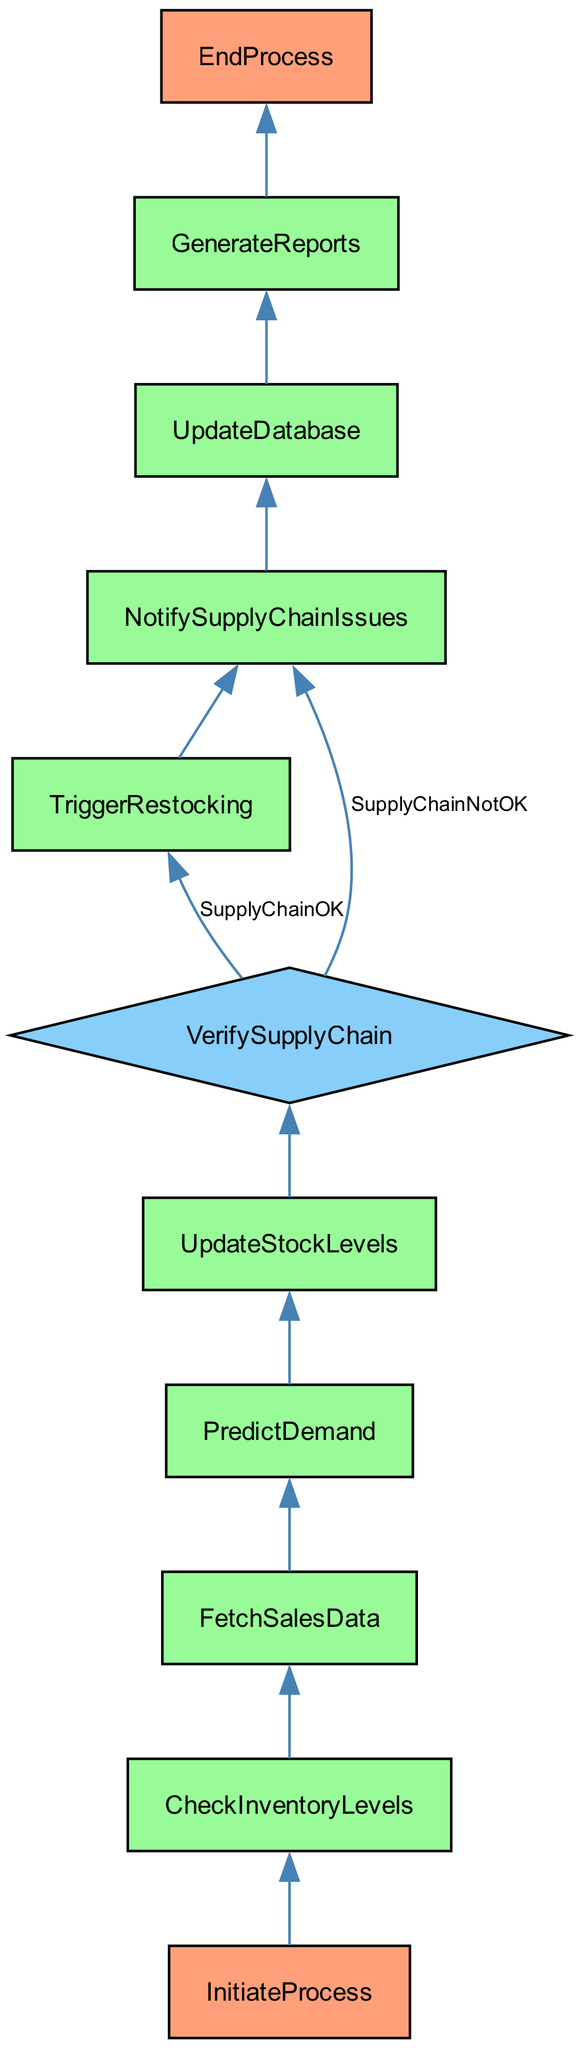What is the first step in the integration process? The first step is indicated by the "InitiateProcess" node, which denotes the starting point of the integration for automated inventory management.
Answer: InitiateProcess Which node checks current inventory levels? The "CheckInventoryLevels" node is responsible for checking the current inventory across all distribution centers as shown in the flowchart.
Answer: CheckInventoryLevels How many processes are there before the verification of the supply chain? There are five processes that occur before reaching the "VerifySupplyChain" decision node, namely: InitiateProcess, CheckInventoryLevels, FetchSalesData, PredictDemand, and UpdateStockLevels.
Answer: Five What happens if the supply chain is verified as okay? If the supply chain is verified as okay, the flowchart shows that it leads to the "TriggerRestocking" process, which automatically orders restocking when inventory is low.
Answer: TriggerRestocking What is the last step indicated in the process? The last step as indicated in the flowchart is "EndProcess," marking the conclusion of the integration process.
Answer: EndProcess Which node generates inventory management reports? The "GenerateReports" node is responsible for generating the inventory management reports as specified in the diagram.
Answer: GenerateReports If stock levels are updated after predicting demand, what is the next node? After updating stock levels in the "UpdateStockLevels" node, the next step is to verify the supply chain in the "VerifySupplyChain" decision node, indicated in the flow.
Answer: VerifySupplyChain What could potentially happen if the supply chain is not okay? If the supply chain verification results in "SupplyChainNotOK," the flow leads to the "NotifySupplyChainIssues" process for manual intervention.
Answer: NotifySupplyChainIssues How many decision points are present in the diagram? The diagram contains one decision point, represented by the "VerifySupplyChain" node, where the flow splits based on supply chain verification.
Answer: One 